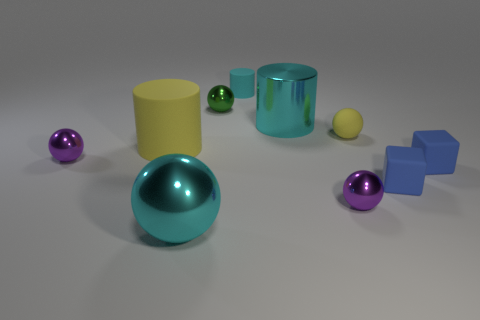Subtract all tiny cylinders. How many cylinders are left? 2 Subtract all purple cylinders. How many purple balls are left? 2 Subtract 3 balls. How many balls are left? 2 Subtract all yellow spheres. How many spheres are left? 4 Subtract all cylinders. How many objects are left? 7 Subtract 0 yellow blocks. How many objects are left? 10 Subtract all purple balls. Subtract all purple cylinders. How many balls are left? 3 Subtract all tiny matte balls. Subtract all cyan things. How many objects are left? 6 Add 3 small cyan cylinders. How many small cyan cylinders are left? 4 Add 6 big rubber cylinders. How many big rubber cylinders exist? 7 